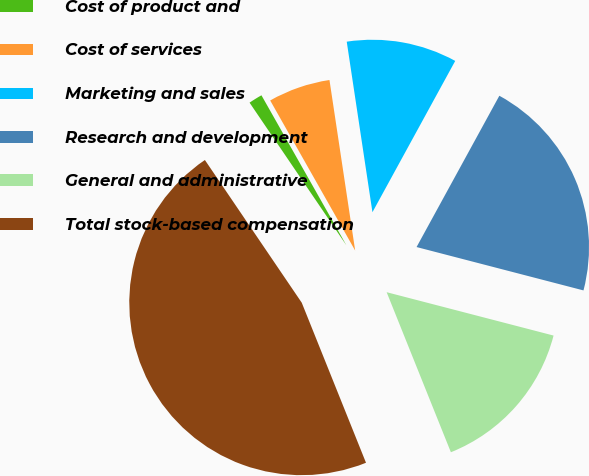<chart> <loc_0><loc_0><loc_500><loc_500><pie_chart><fcel>Cost of product and<fcel>Cost of services<fcel>Marketing and sales<fcel>Research and development<fcel>General and administrative<fcel>Total stock-based compensation<nl><fcel>1.29%<fcel>5.82%<fcel>10.35%<fcel>21.08%<fcel>14.88%<fcel>46.59%<nl></chart> 